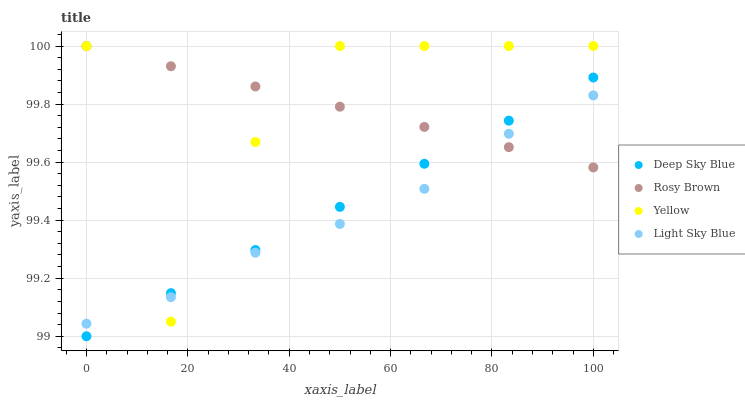Does Light Sky Blue have the minimum area under the curve?
Answer yes or no. Yes. Does Rosy Brown have the maximum area under the curve?
Answer yes or no. Yes. Does Yellow have the minimum area under the curve?
Answer yes or no. No. Does Yellow have the maximum area under the curve?
Answer yes or no. No. Is Deep Sky Blue the smoothest?
Answer yes or no. Yes. Is Yellow the roughest?
Answer yes or no. Yes. Is Yellow the smoothest?
Answer yes or no. No. Is Deep Sky Blue the roughest?
Answer yes or no. No. Does Deep Sky Blue have the lowest value?
Answer yes or no. Yes. Does Yellow have the lowest value?
Answer yes or no. No. Does Yellow have the highest value?
Answer yes or no. Yes. Does Deep Sky Blue have the highest value?
Answer yes or no. No. Does Rosy Brown intersect Yellow?
Answer yes or no. Yes. Is Rosy Brown less than Yellow?
Answer yes or no. No. Is Rosy Brown greater than Yellow?
Answer yes or no. No. 